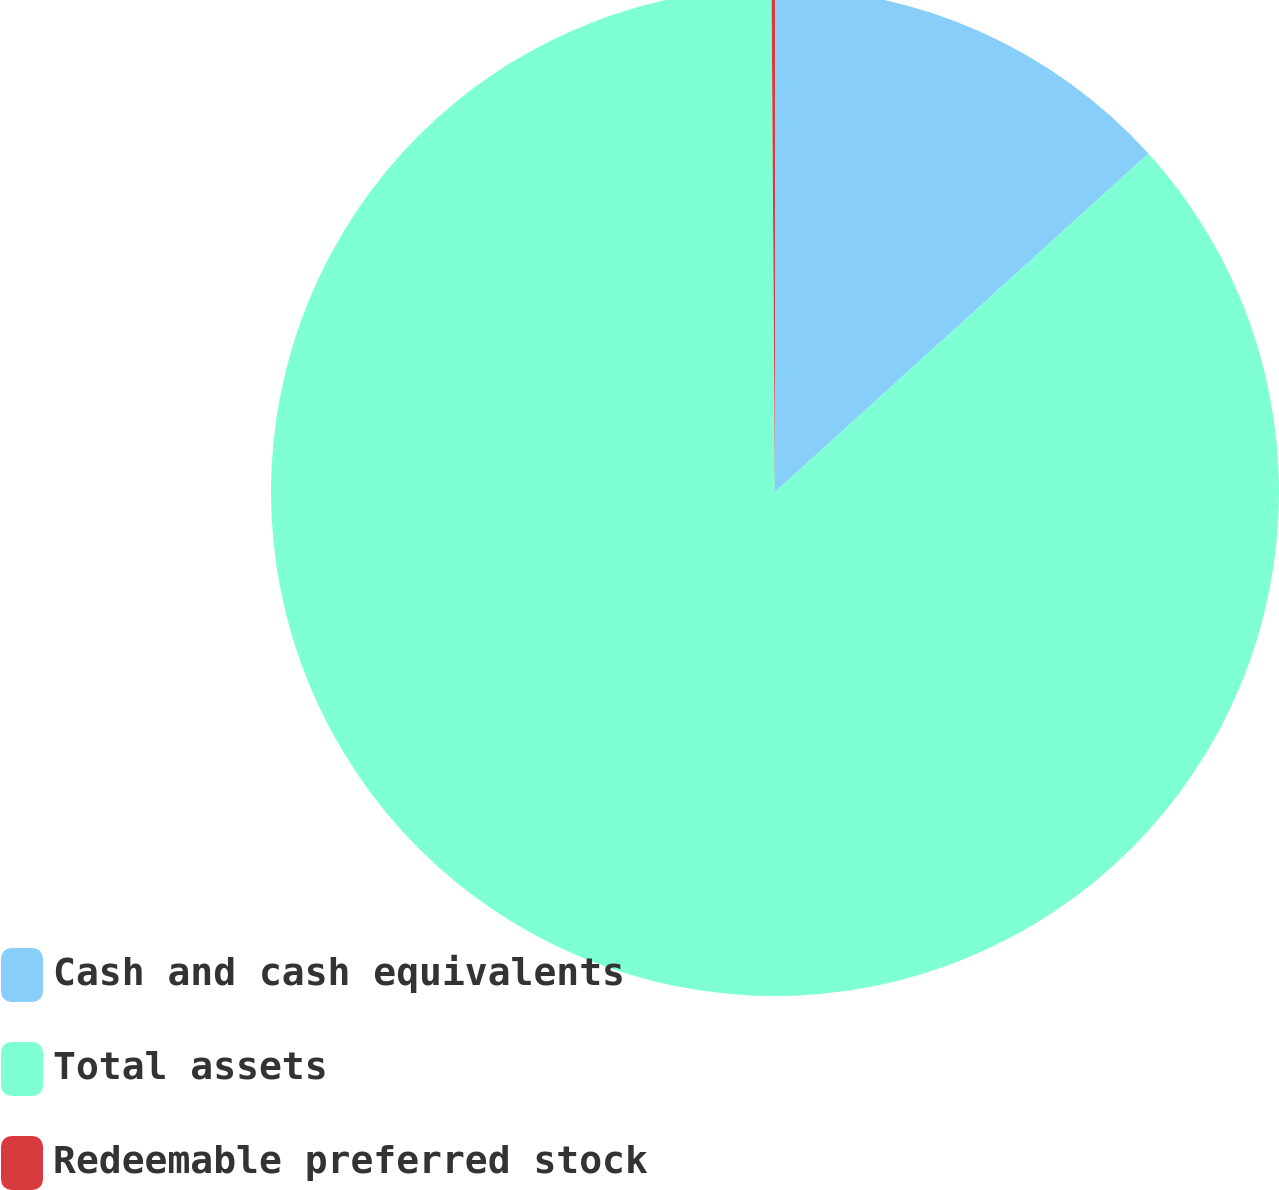<chart> <loc_0><loc_0><loc_500><loc_500><pie_chart><fcel>Cash and cash equivalents<fcel>Total assets<fcel>Redeemable preferred stock<nl><fcel>13.28%<fcel>86.6%<fcel>0.11%<nl></chart> 